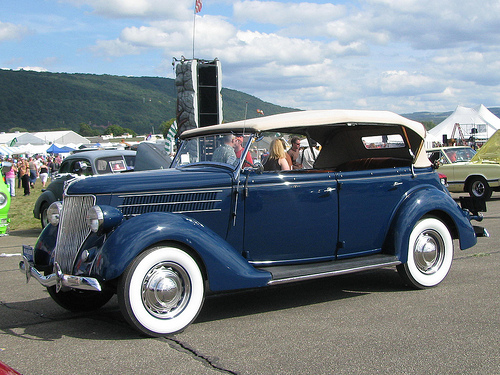<image>
Can you confirm if the woman is in the car? No. The woman is not contained within the car. These objects have a different spatial relationship. 